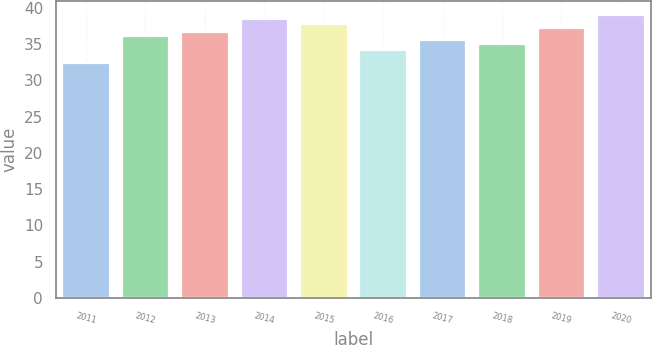Convert chart. <chart><loc_0><loc_0><loc_500><loc_500><bar_chart><fcel>2011<fcel>2012<fcel>2013<fcel>2014<fcel>2015<fcel>2016<fcel>2017<fcel>2018<fcel>2019<fcel>2020<nl><fcel>32.45<fcel>36.11<fcel>36.68<fcel>38.39<fcel>37.82<fcel>34.12<fcel>35.54<fcel>34.97<fcel>37.25<fcel>38.96<nl></chart> 